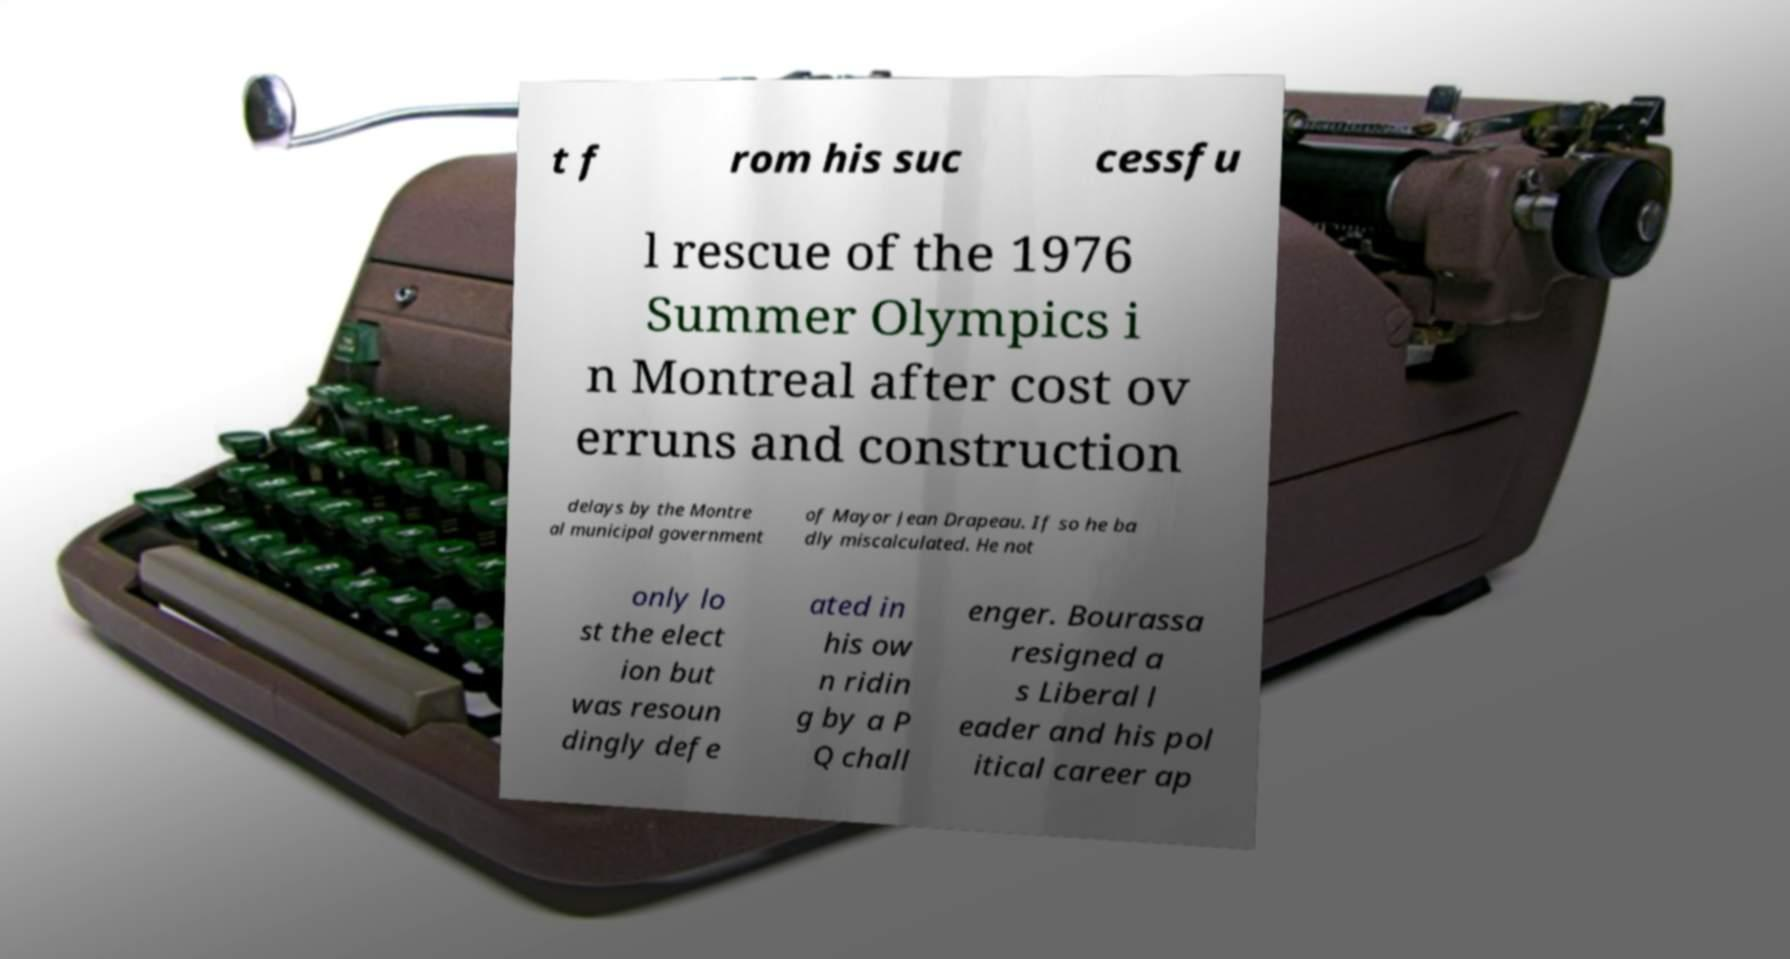Please read and relay the text visible in this image. What does it say? t f rom his suc cessfu l rescue of the 1976 Summer Olympics i n Montreal after cost ov erruns and construction delays by the Montre al municipal government of Mayor Jean Drapeau. If so he ba dly miscalculated. He not only lo st the elect ion but was resoun dingly defe ated in his ow n ridin g by a P Q chall enger. Bourassa resigned a s Liberal l eader and his pol itical career ap 